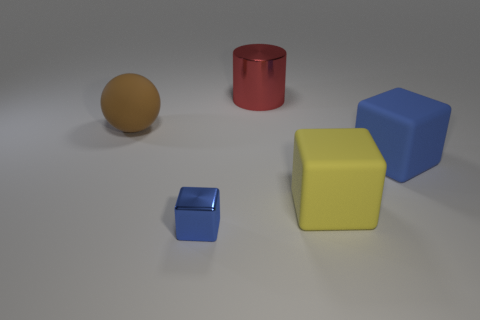Are there fewer tiny blue metallic things left of the brown object than big rubber balls?
Offer a terse response. Yes. Is the shape of the tiny shiny thing the same as the large red object?
Make the answer very short. No. There is a block that is to the left of the large metallic object; how big is it?
Offer a terse response. Small. What is the size of the yellow object that is made of the same material as the large brown sphere?
Provide a succinct answer. Large. Are there fewer tiny purple cubes than small shiny things?
Your answer should be very brief. Yes. There is a brown sphere that is the same size as the yellow rubber block; what is its material?
Keep it short and to the point. Rubber. Is the number of large green metallic cubes greater than the number of brown things?
Your answer should be compact. No. What number of other objects are the same color as the cylinder?
Offer a very short reply. 0. What number of things are behind the tiny blue object and left of the large shiny cylinder?
Provide a short and direct response. 1. Is there anything else that is the same size as the yellow rubber block?
Ensure brevity in your answer.  Yes. 